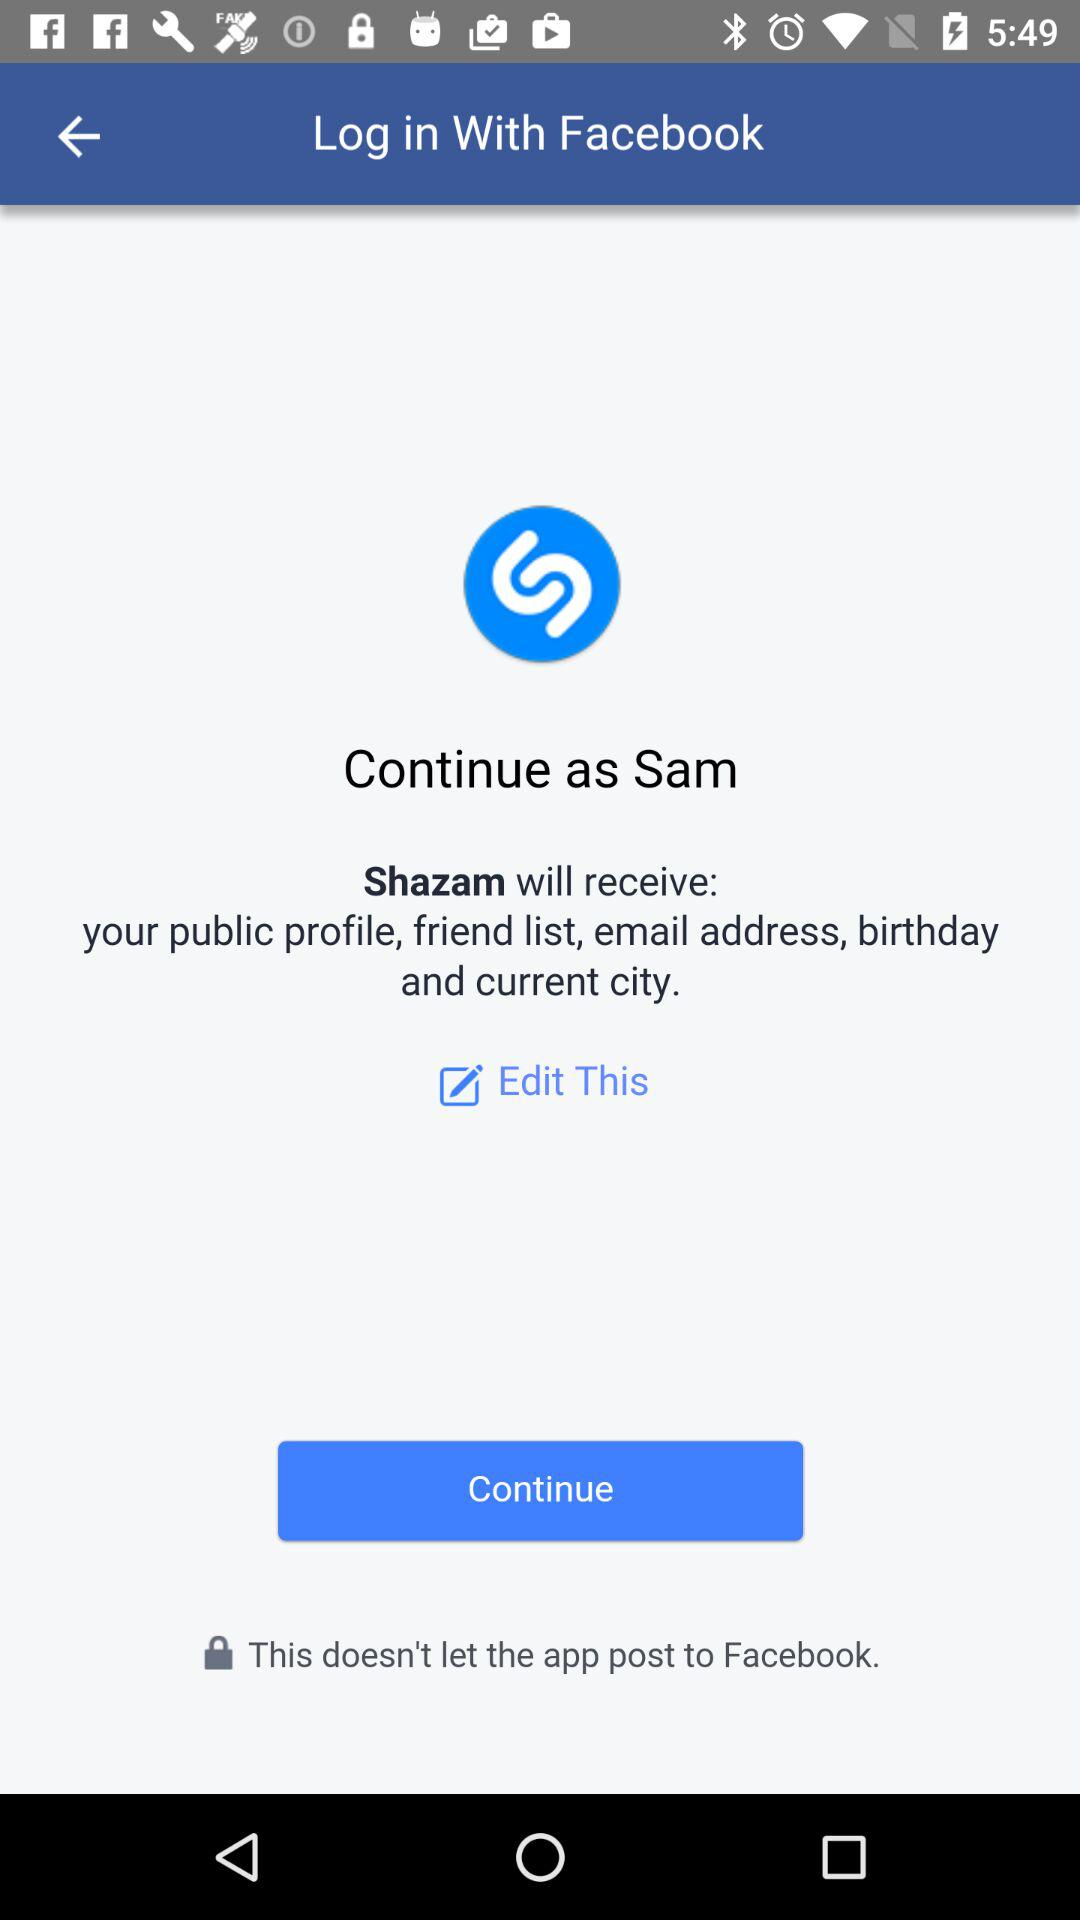What is the name of the user? The name of the user is Sam. 